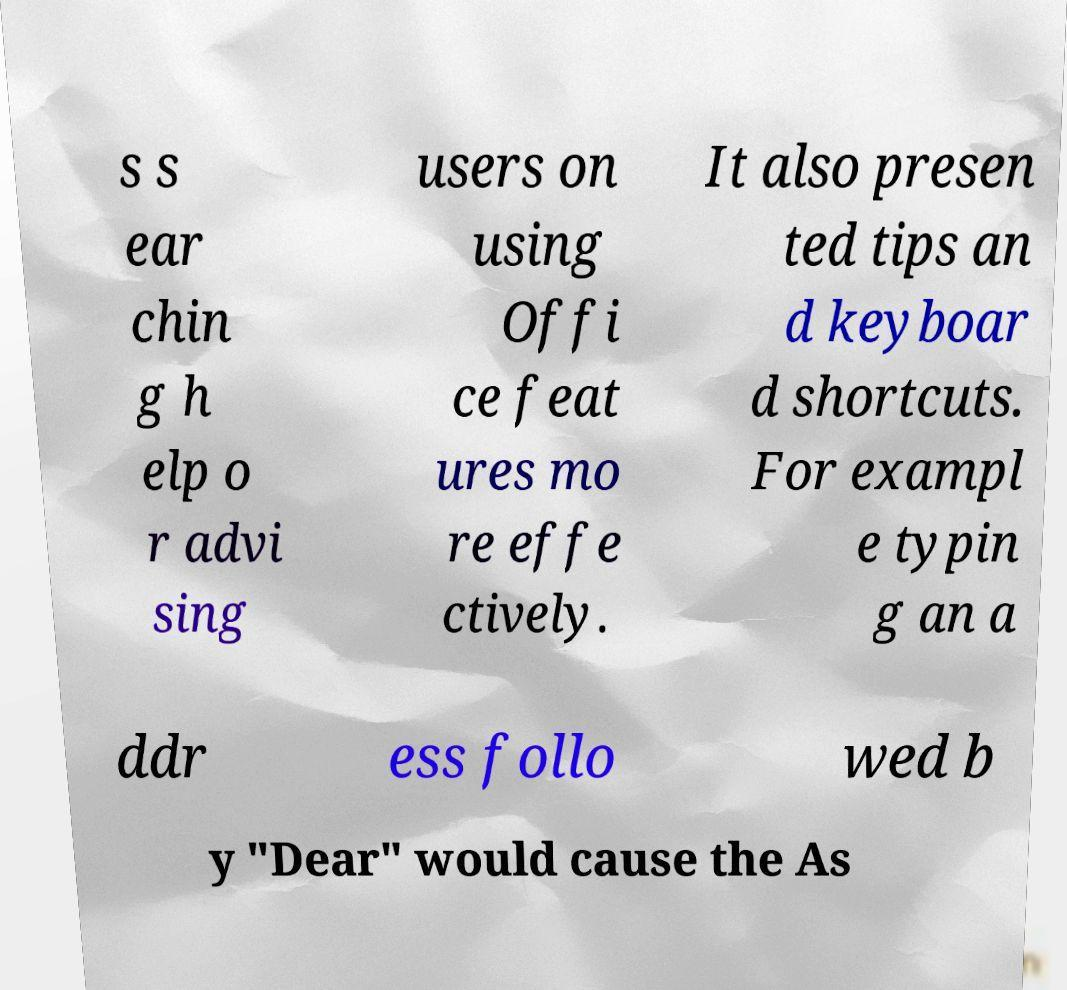Can you read and provide the text displayed in the image?This photo seems to have some interesting text. Can you extract and type it out for me? s s ear chin g h elp o r advi sing users on using Offi ce feat ures mo re effe ctively. It also presen ted tips an d keyboar d shortcuts. For exampl e typin g an a ddr ess follo wed b y "Dear" would cause the As 